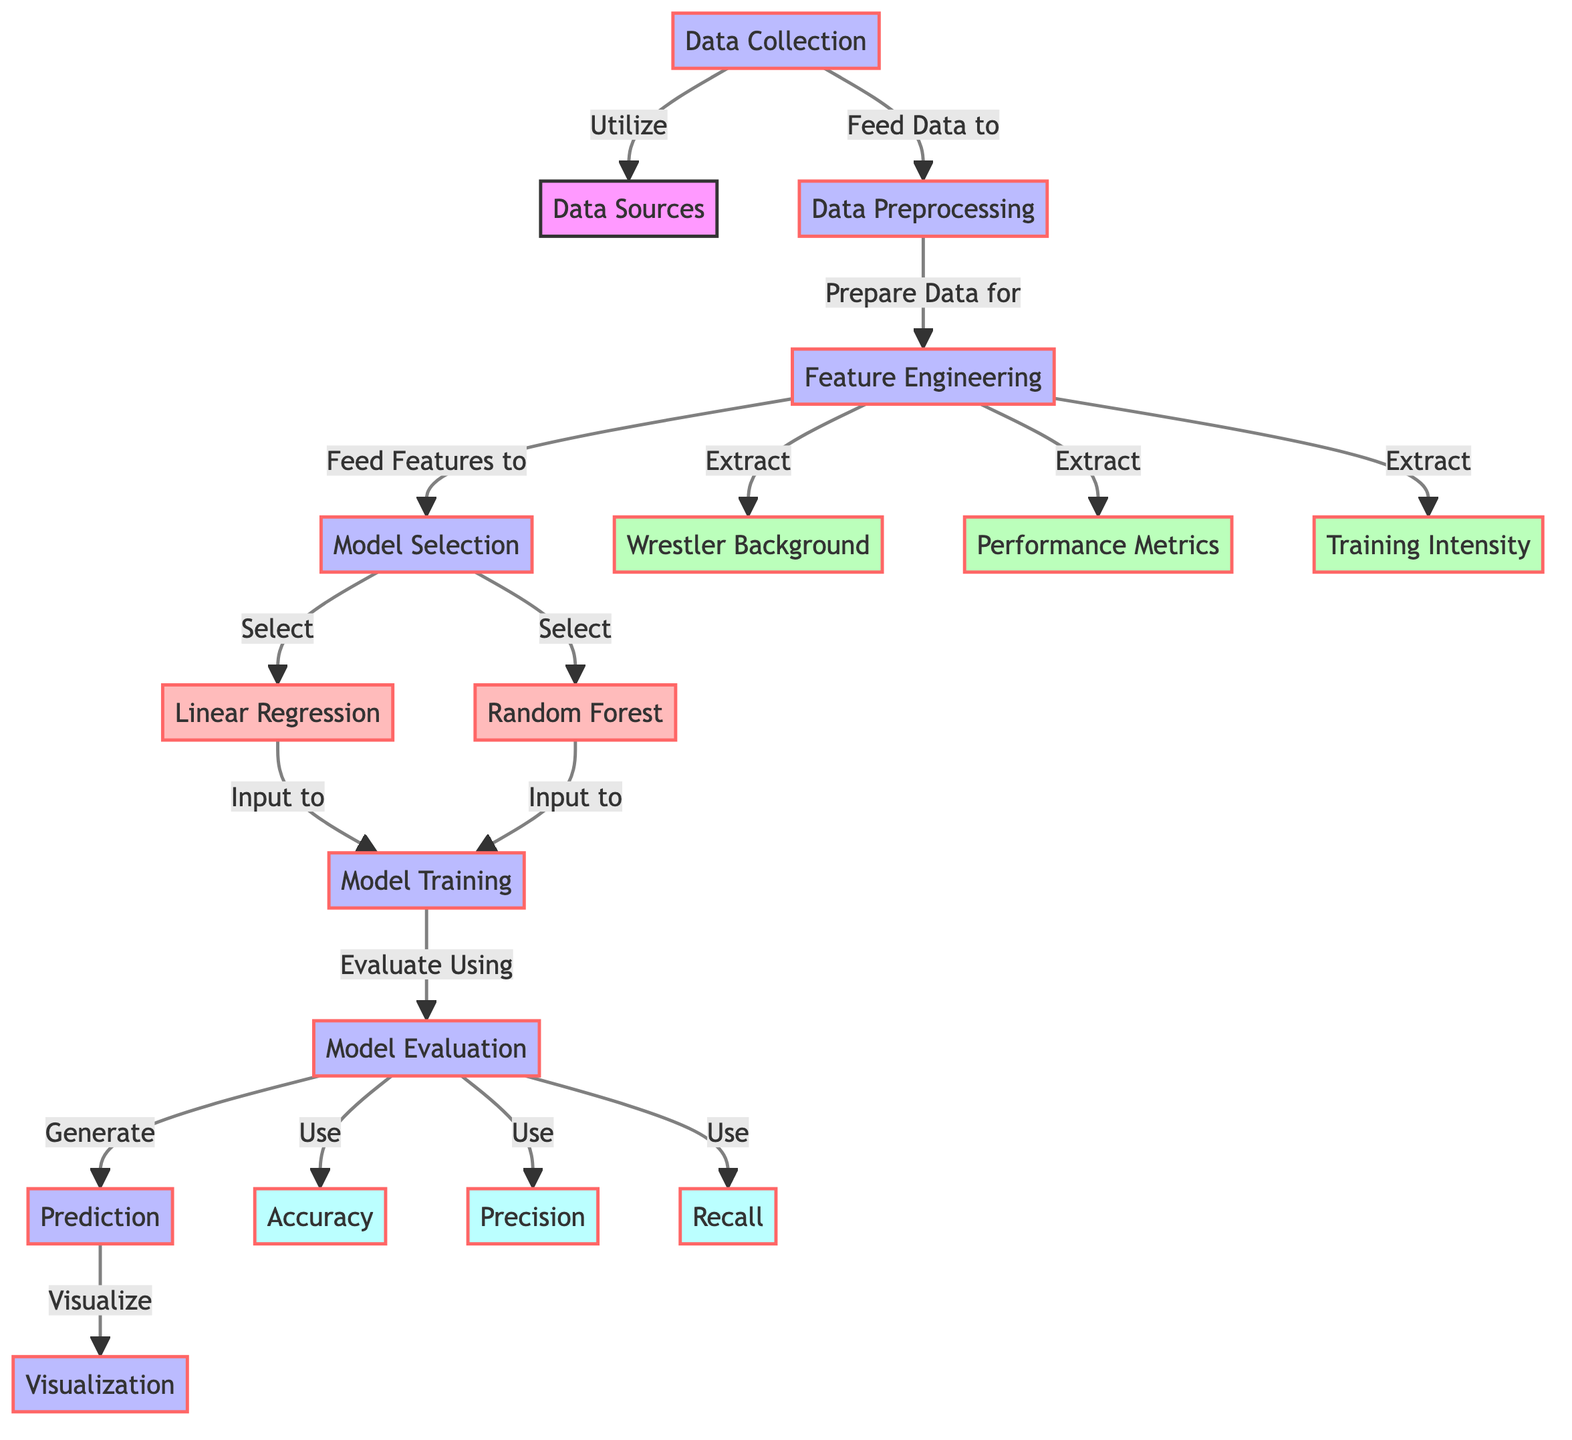What is the first step in this diagram? The first step in the diagram is "Data Collection," which indicates that data must be collected before any processing can occur.
Answer: Data Collection How many features are extracted in the feature engineering step? In the feature engineering step, three features are extracted: "Wrestler Background," "Performance Metrics," and "Training Intensity," hence the total is three features.
Answer: 3 Which evaluation metric is associated with accuracy? The evaluation metric associated with accuracy is labeled as "Accuracy," indicating its direct relevance to model performance evaluation.
Answer: Accuracy What models are selected in the model selection process? The models selected in the model selection process are "Linear Regression" and "Random Forest," as shown in the diagram.
Answer: Linear Regression and Random Forest What is the final output of the diagram after all the processes? The final output of the diagram after all processes is "Visualization," which is the last step that synthesizes the predictions into a visual format.
Answer: Visualization Which process prepares the data for feature extraction? The process that prepares the data for feature extraction is "Data Preprocessing," occurring immediately after data collection in the flow of the diagram.
Answer: Data Preprocessing Which step evaluates the models using defined metrics? The step that evaluates the models using defined metrics is "Model Evaluation," which occurs after the model training step in the workflow.
Answer: Model Evaluation How are features fed into the model selection process? Features are fed into the model selection process as a result of the output from the feature engineering step, signifying a sequential flow in the diagram.
Answer: Features from Feature Engineering What is the relationship between model training and prediction in the diagram? The relationship is that model training leads to the generation of predictions, as indicated by the arrow connecting "Model Training" to "Prediction."
Answer: Model Training leads to Prediction 